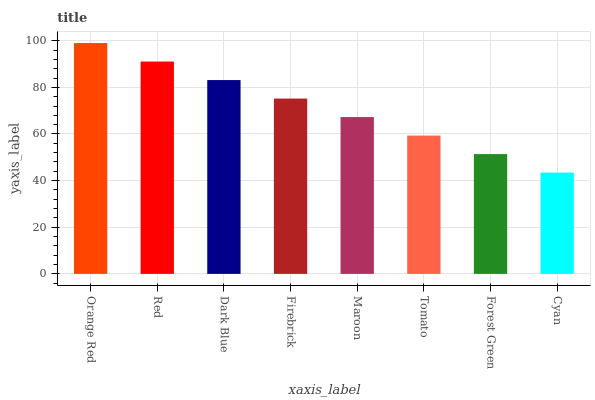Is Cyan the minimum?
Answer yes or no. Yes. Is Orange Red the maximum?
Answer yes or no. Yes. Is Red the minimum?
Answer yes or no. No. Is Red the maximum?
Answer yes or no. No. Is Orange Red greater than Red?
Answer yes or no. Yes. Is Red less than Orange Red?
Answer yes or no. Yes. Is Red greater than Orange Red?
Answer yes or no. No. Is Orange Red less than Red?
Answer yes or no. No. Is Firebrick the high median?
Answer yes or no. Yes. Is Maroon the low median?
Answer yes or no. Yes. Is Orange Red the high median?
Answer yes or no. No. Is Tomato the low median?
Answer yes or no. No. 